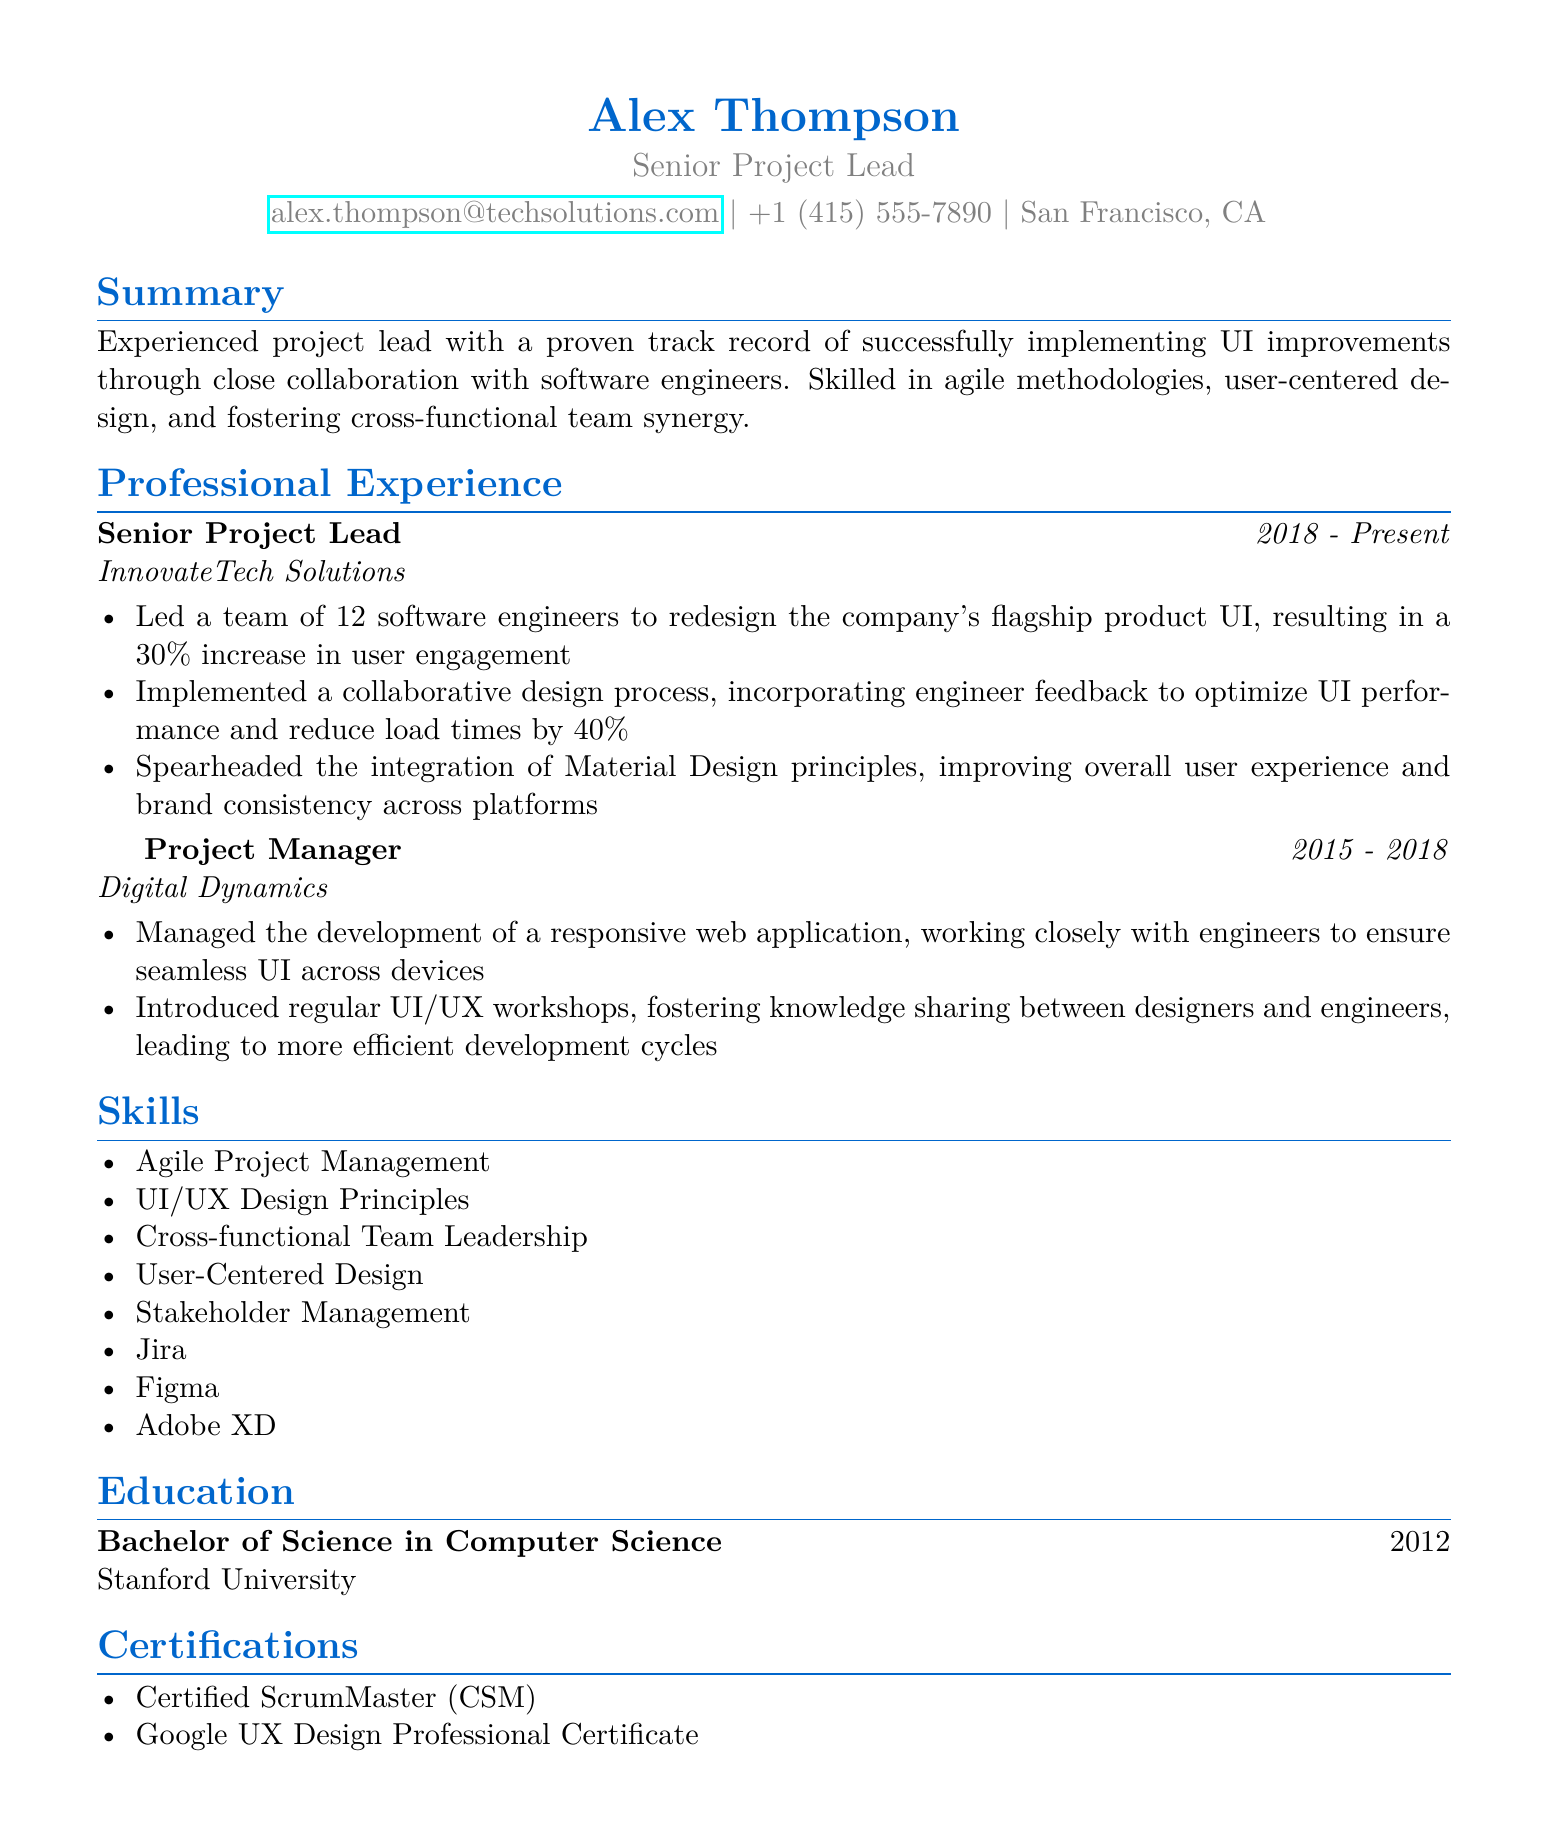What is the name of the project lead? The document specifies the name of the project lead as Alex Thompson.
Answer: Alex Thompson What is Alex Thompson’s current title? The title of Alex Thompson, as stated in the document, is Senior Project Lead.
Answer: Senior Project Lead Which company does Alex Thompson currently work for? The document mentions InnovateTech Solutions as the current employer of Alex Thompson.
Answer: InnovateTech Solutions What percentage increase in user engagement was achieved after the UI redesign? According to the document, the redesign of the UI resulted in a 30% increase in user engagement.
Answer: 30% How many years did Alex Thompson work as a Project Manager? The duration of the Project Manager position is from 2015 to 2018, totaling three years.
Answer: 3 years What certification does Alex Thompson hold related to Scrum? The document states that Alex Thompson is a Certified ScrumMaster (CSM).
Answer: Certified ScrumMaster (CSM) What specific process was implemented to improve UI performance? The document indicates that a collaborative design process incorporating engineer feedback was implemented.
Answer: Collaborative design process What principle was integrated to improve user experience? The document mentions the integration of Material Design principles for improving user experience.
Answer: Material Design principles In what year did Alex Thompson graduate from Stanford University? The document states that Alex Thompson graduated from Stanford University in 2012.
Answer: 2012 